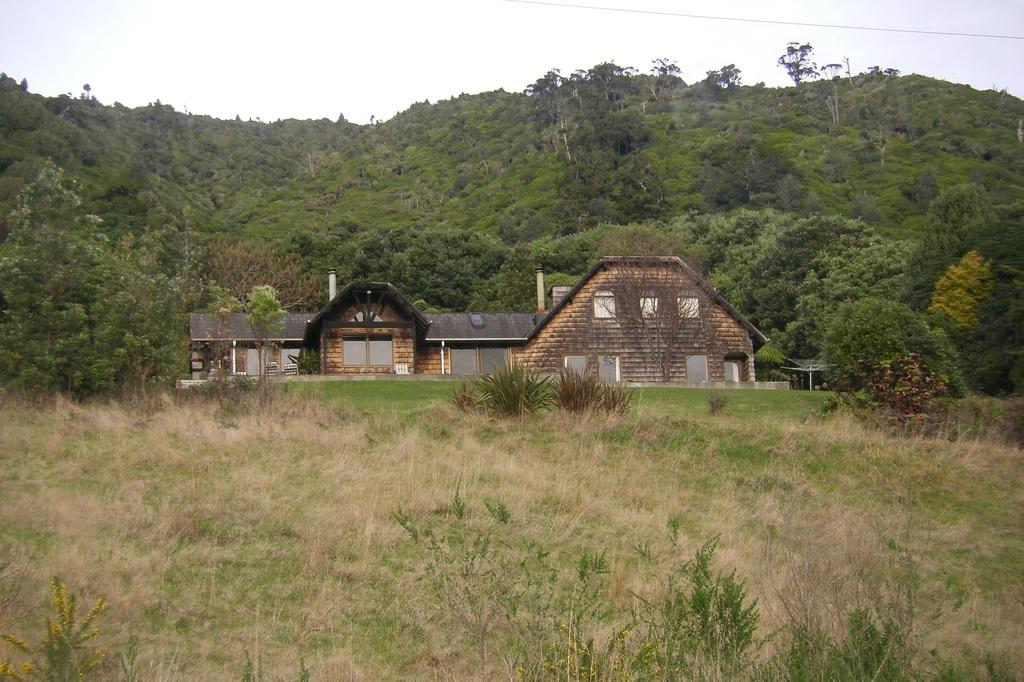What type of living organisms can be seen in the image? Plants and trees are visible in the image. What type of structure is present in the image? There is a house with windows in the image. What can be seen in the background of the image? The sky is visible in the background of the image. Can you see a receipt for the plants in the image? There is no receipt present in the image. Is there a thunderstorm happening in the image? There is no indication of a thunderstorm in the image; the sky is visible in the background, but no storm is depicted. 